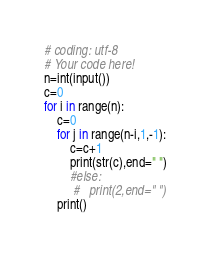Convert code to text. <code><loc_0><loc_0><loc_500><loc_500><_Python_># coding: utf-8
# Your code here!
n=int(input())
c=0
for i in range(n):
    c=0
    for j in range(n-i,1,-1):
        c=c+1
        print(str(c),end=" ")
        #else:
         #   print(2,end=" ")
    print()</code> 